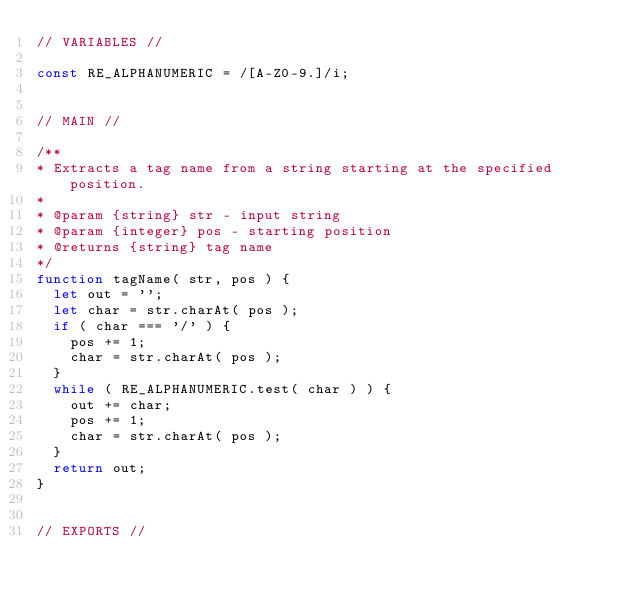<code> <loc_0><loc_0><loc_500><loc_500><_JavaScript_>// VARIABLES //

const RE_ALPHANUMERIC = /[A-Z0-9.]/i;


// MAIN //

/**
* Extracts a tag name from a string starting at the specified position.
*
* @param {string} str - input string
* @param {integer} pos - starting position
* @returns {string} tag name
*/
function tagName( str, pos ) {
	let out = '';
	let char = str.charAt( pos );
	if ( char === '/' ) {
		pos += 1;
		char = str.charAt( pos );
	}
	while ( RE_ALPHANUMERIC.test( char ) ) {
		out += char;
		pos += 1;
		char = str.charAt( pos );
	}
	return out;
}


// EXPORTS //
</code> 